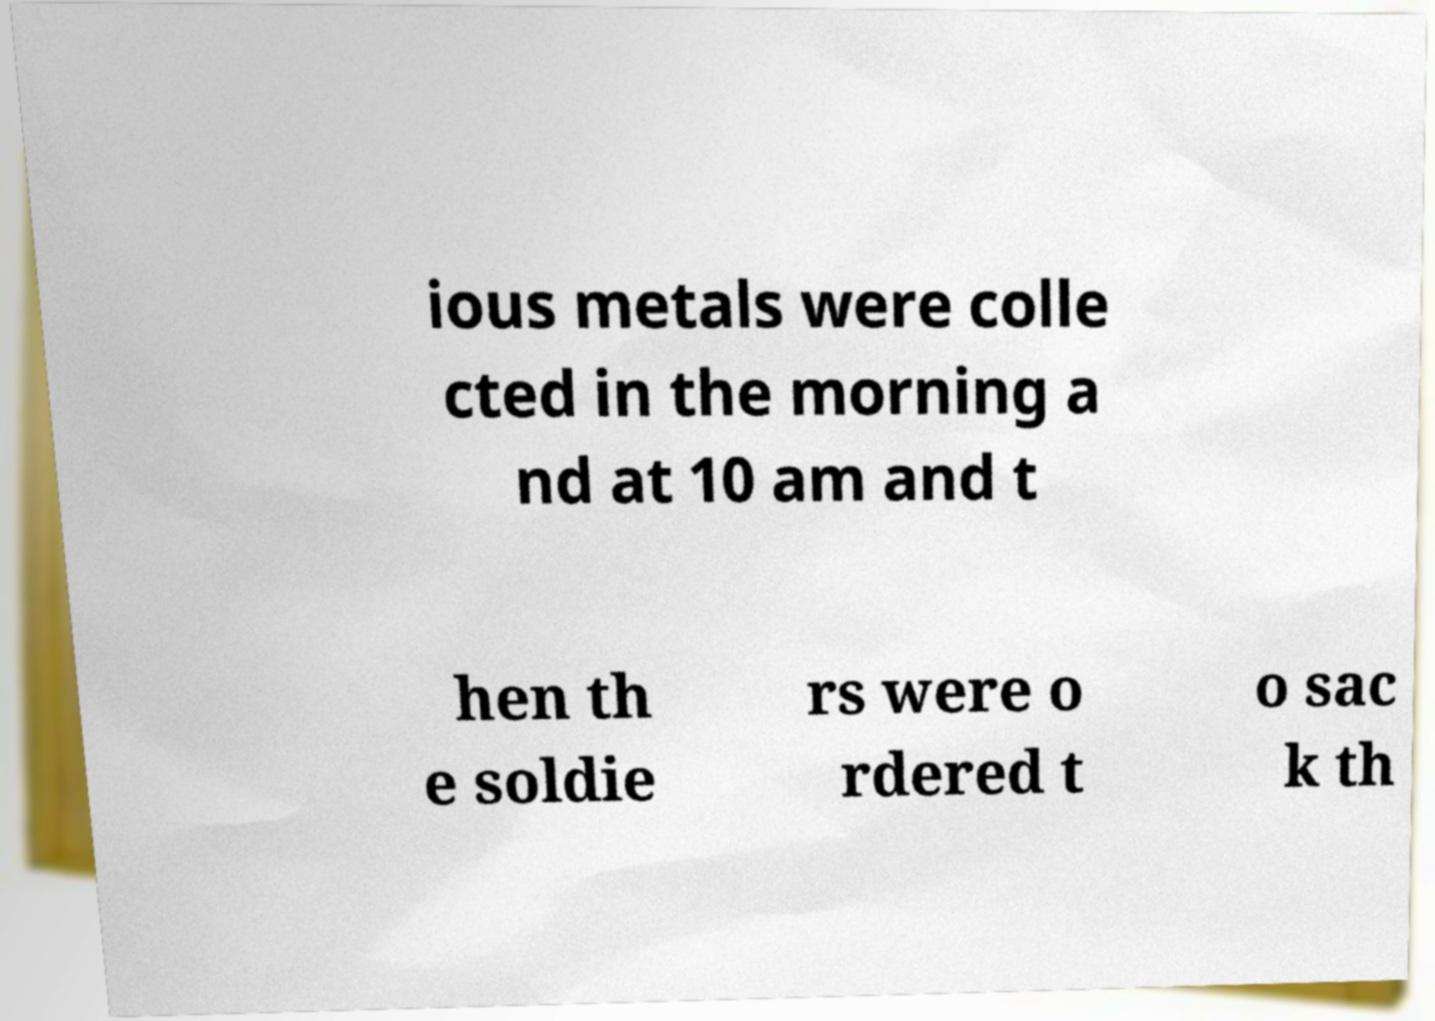Please identify and transcribe the text found in this image. ious metals were colle cted in the morning a nd at 10 am and t hen th e soldie rs were o rdered t o sac k th 